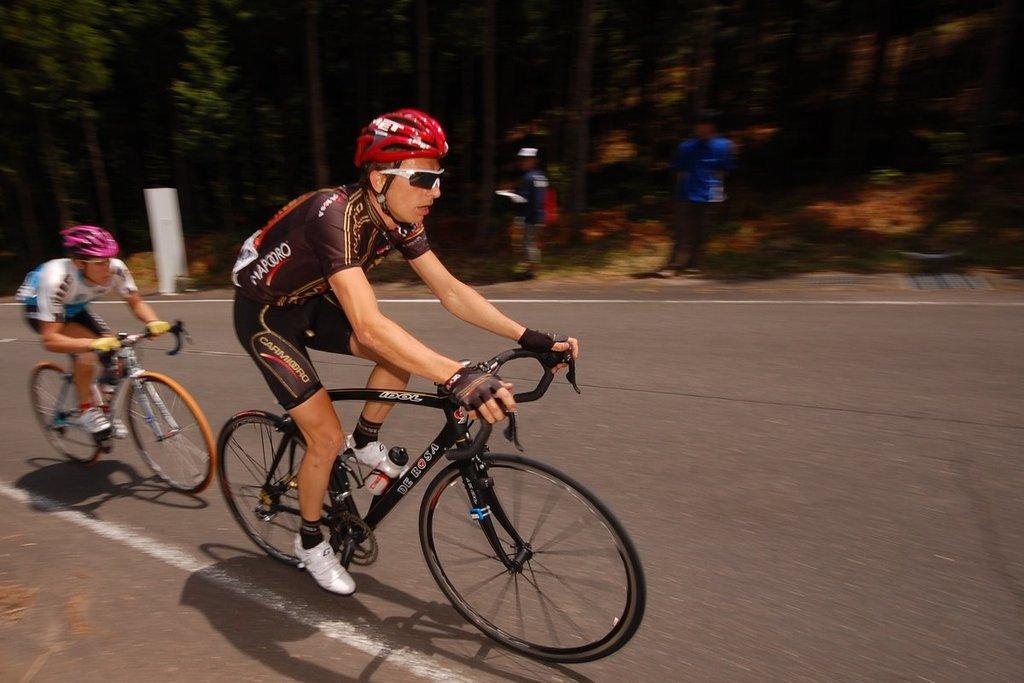Can you describe this image briefly? In the middle of the image two persons are riding bicycles on the road. At the top of the image two persons are standing and watching. Behind them we can see some trees. Background of the image is blur. 